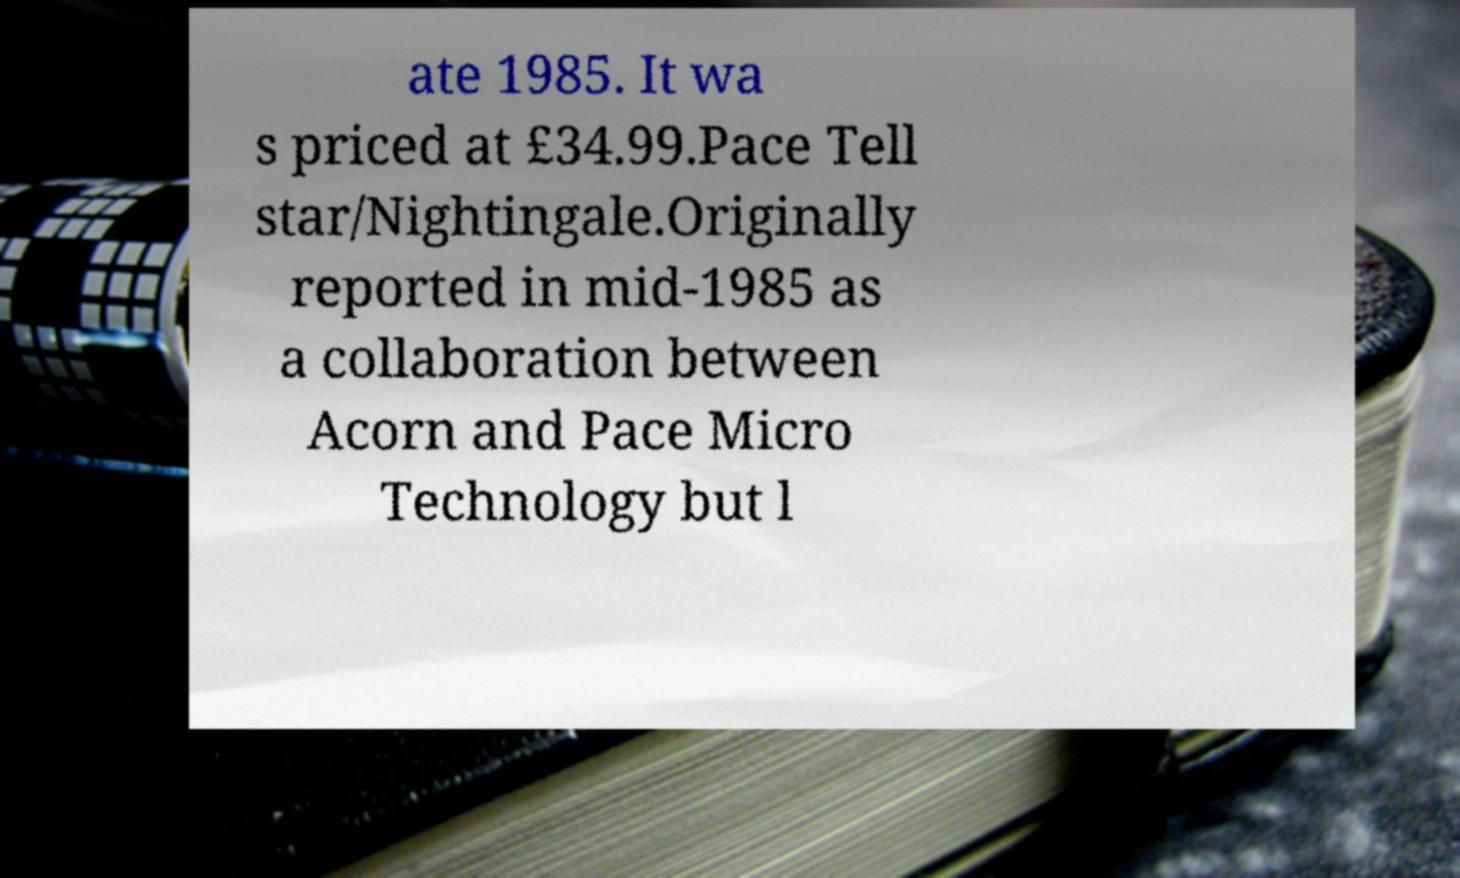Could you extract and type out the text from this image? ate 1985. It wa s priced at £34.99.Pace Tell star/Nightingale.Originally reported in mid-1985 as a collaboration between Acorn and Pace Micro Technology but l 